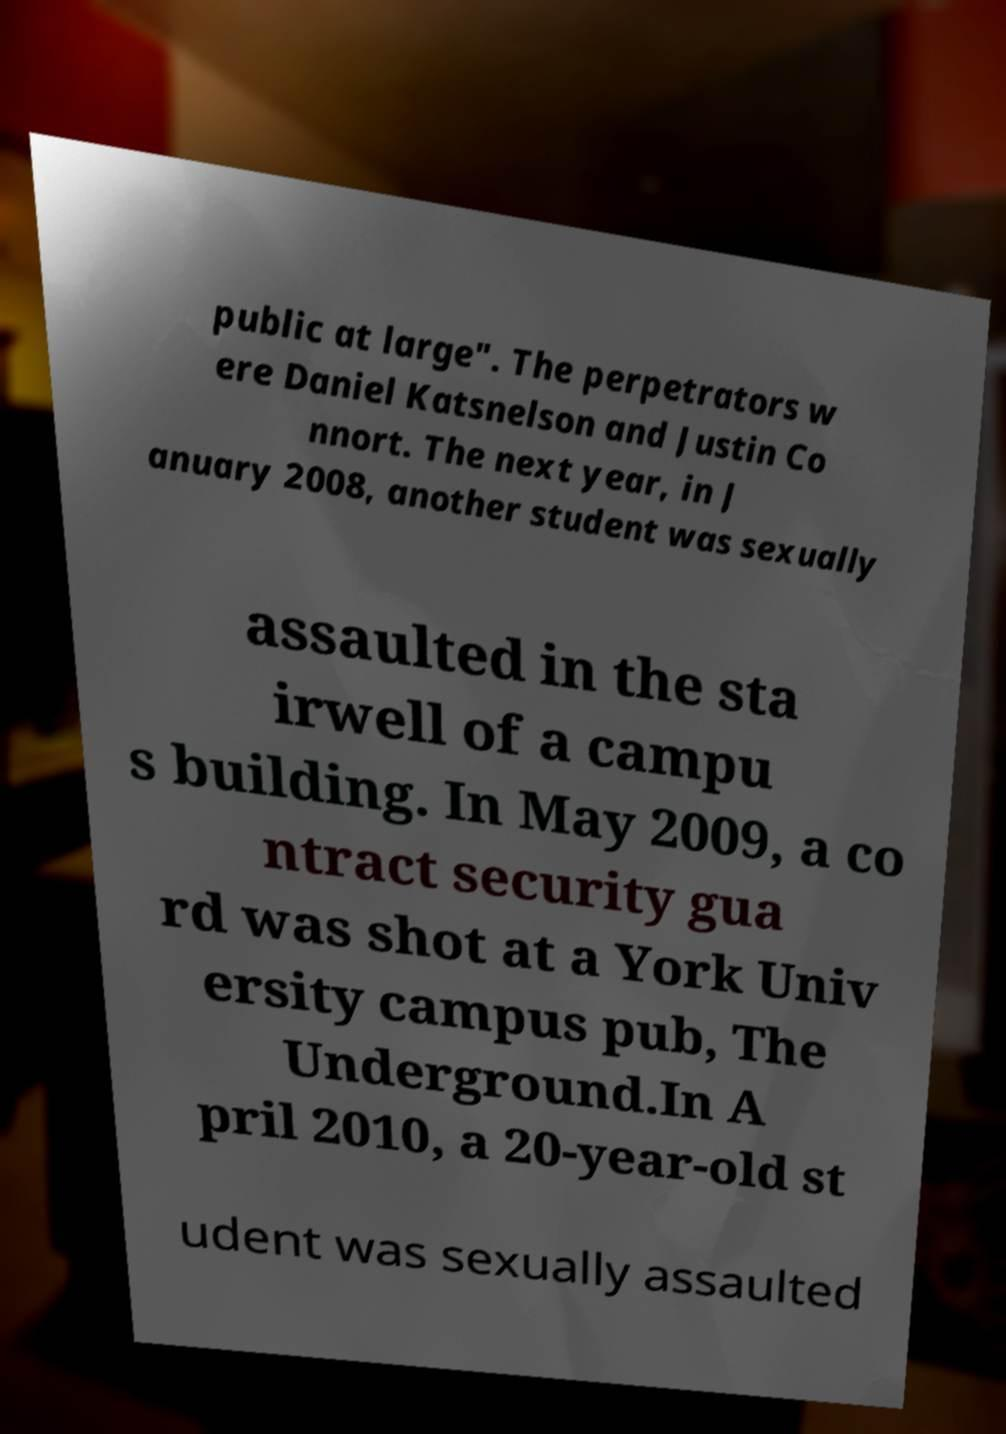Please read and relay the text visible in this image. What does it say? public at large". The perpetrators w ere Daniel Katsnelson and Justin Co nnort. The next year, in J anuary 2008, another student was sexually assaulted in the sta irwell of a campu s building. In May 2009, a co ntract security gua rd was shot at a York Univ ersity campus pub, The Underground.In A pril 2010, a 20-year-old st udent was sexually assaulted 